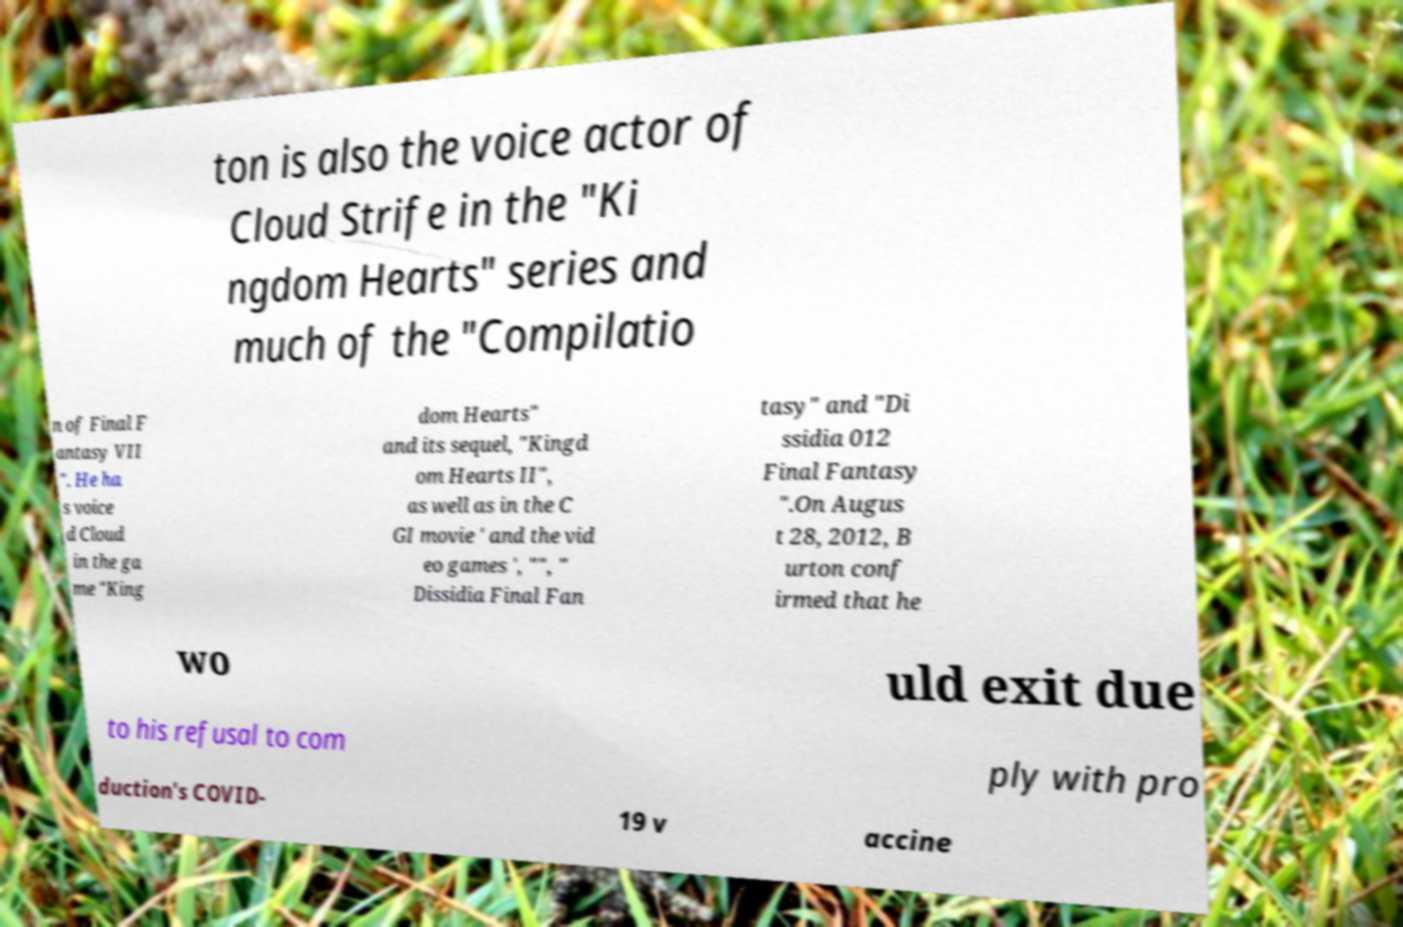I need the written content from this picture converted into text. Can you do that? ton is also the voice actor of Cloud Strife in the "Ki ngdom Hearts" series and much of the "Compilatio n of Final F antasy VII ". He ha s voice d Cloud in the ga me "King dom Hearts" and its sequel, "Kingd om Hearts II", as well as in the C GI movie ' and the vid eo games ', "", " Dissidia Final Fan tasy" and "Di ssidia 012 Final Fantasy ".On Augus t 28, 2012, B urton conf irmed that he wo uld exit due to his refusal to com ply with pro duction's COVID- 19 v accine 